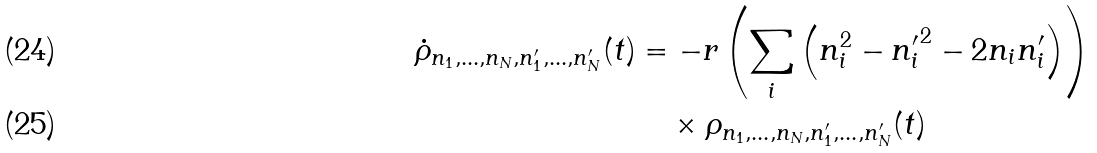<formula> <loc_0><loc_0><loc_500><loc_500>\dot { \rho } _ { n _ { 1 } , \dots , n _ { N } , n ^ { \prime } _ { 1 } , \dots , n ^ { \prime } _ { N } } ( t ) & = - r \left ( \sum _ { i } \left ( n _ { i } ^ { 2 } - { n _ { i } ^ { \prime } } ^ { 2 } - 2 n _ { i } n _ { i } ^ { \prime } \right ) \right ) \\ & \quad \times \rho _ { n _ { 1 } , \dots , n _ { N } , n ^ { \prime } _ { 1 } , \dots , n ^ { \prime } _ { N } } ( t )</formula> 